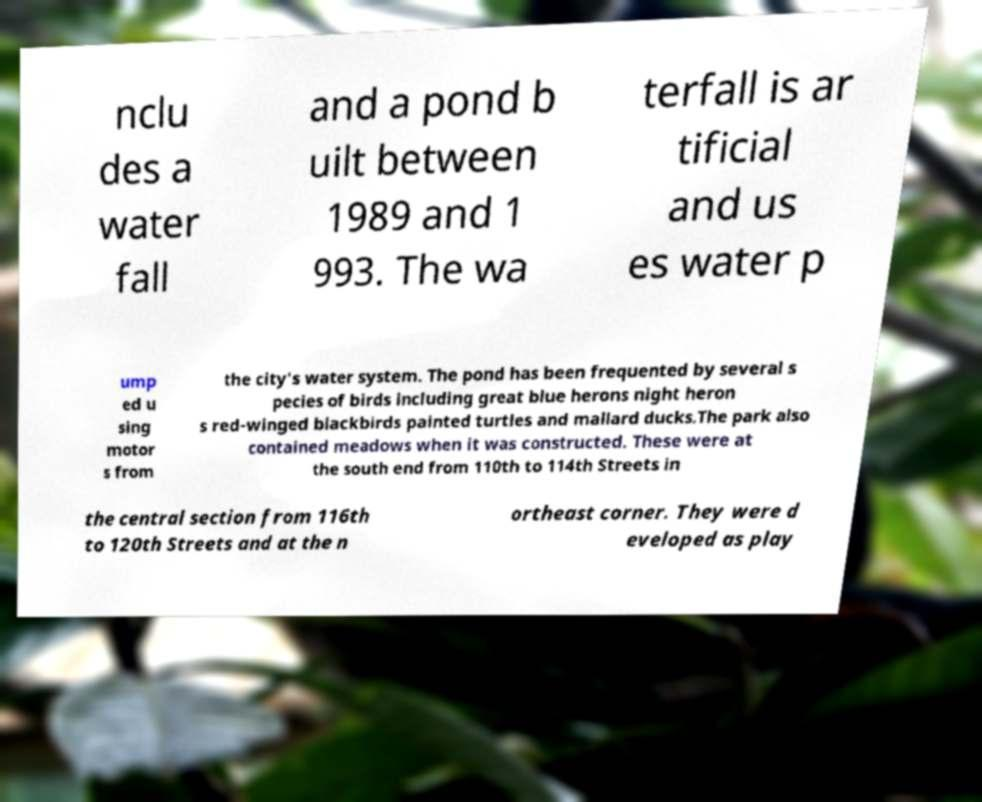Please read and relay the text visible in this image. What does it say? nclu des a water fall and a pond b uilt between 1989 and 1 993. The wa terfall is ar tificial and us es water p ump ed u sing motor s from the city's water system. The pond has been frequented by several s pecies of birds including great blue herons night heron s red-winged blackbirds painted turtles and mallard ducks.The park also contained meadows when it was constructed. These were at the south end from 110th to 114th Streets in the central section from 116th to 120th Streets and at the n ortheast corner. They were d eveloped as play 